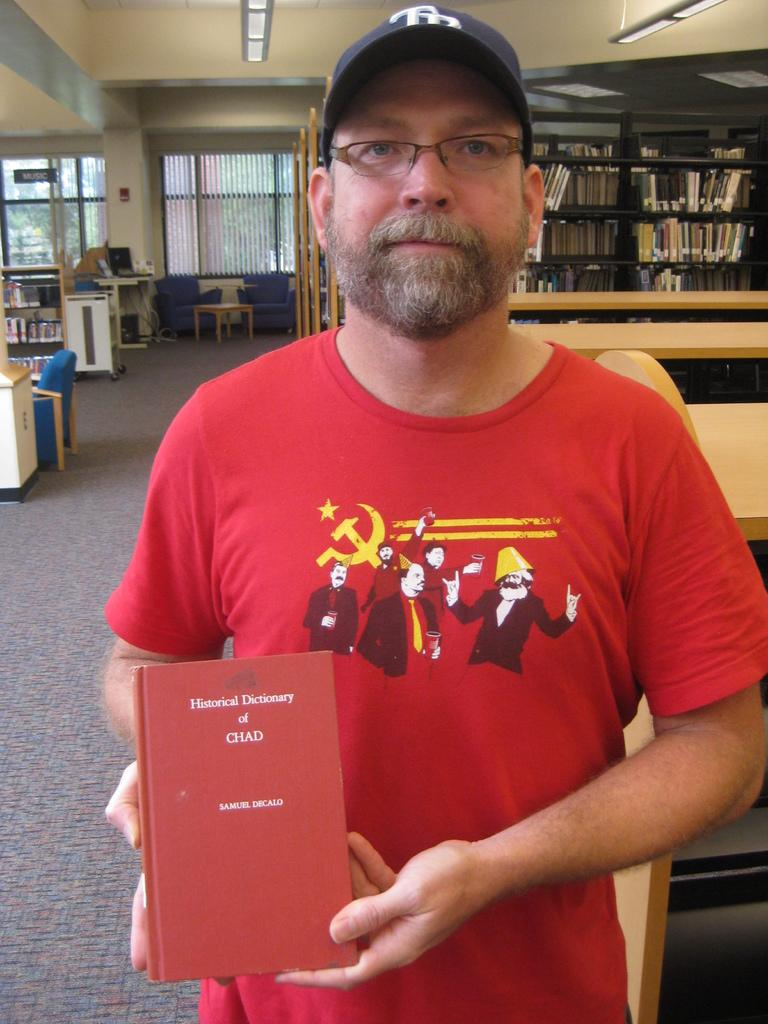<image>
Share a concise interpretation of the image provided. A man wearing a red shirt, is holding Samuel Decalo's Historical Dictonary of Chat. 